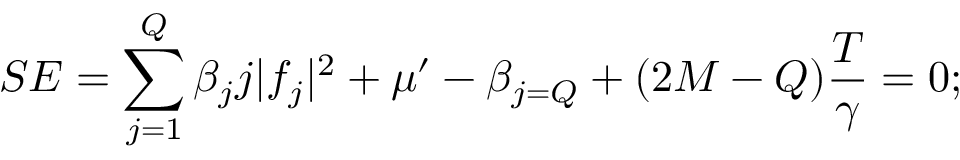<formula> <loc_0><loc_0><loc_500><loc_500>S E = \sum _ { j = 1 } ^ { Q } \beta _ { j } j | f _ { j } | ^ { 2 } + \mu ^ { \prime } - \beta _ { j = Q } + ( 2 M - Q ) \frac { T } { \gamma } = 0 ;</formula> 